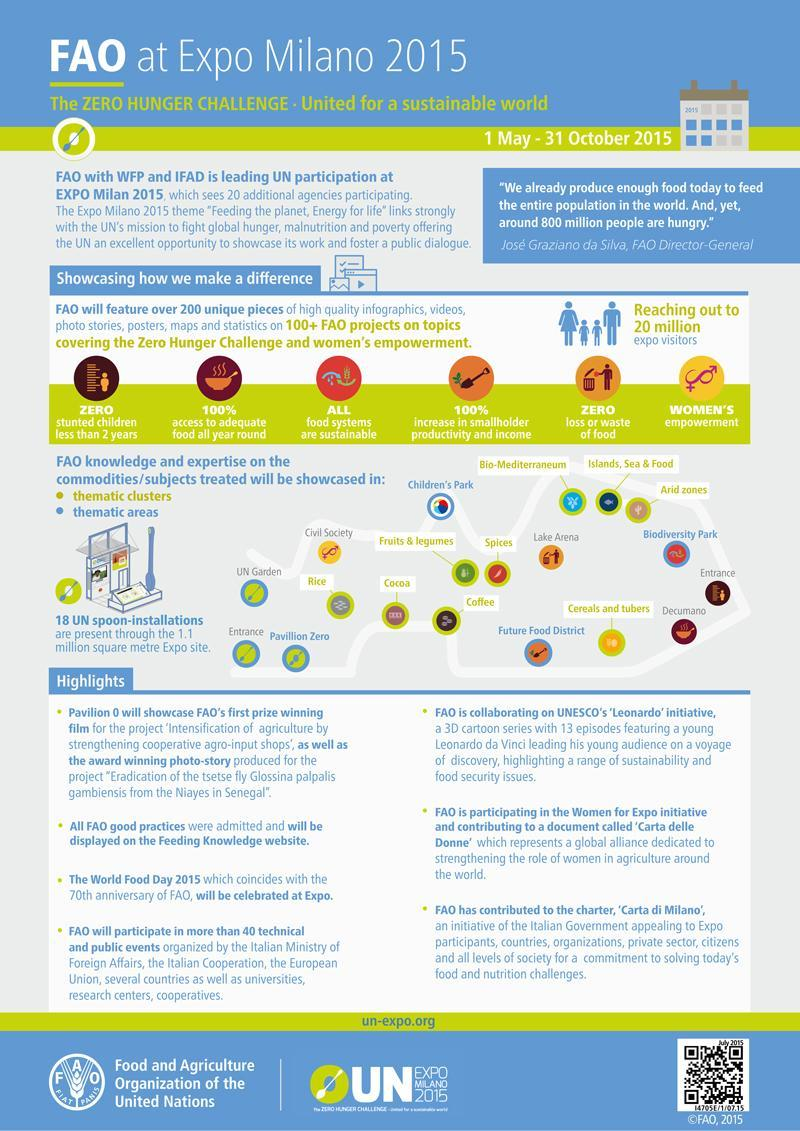How many people visited the Expo Milano 2015?
Answer the question with a short phrase. 20 million What percentage increase in smallholder productivity & income is expected by the FAO projects? 100% What is the area covered by Expo Milano 2015? 1.1 million square metre How many UN spoon-installations were present at the Expo Milano 2015? 18 